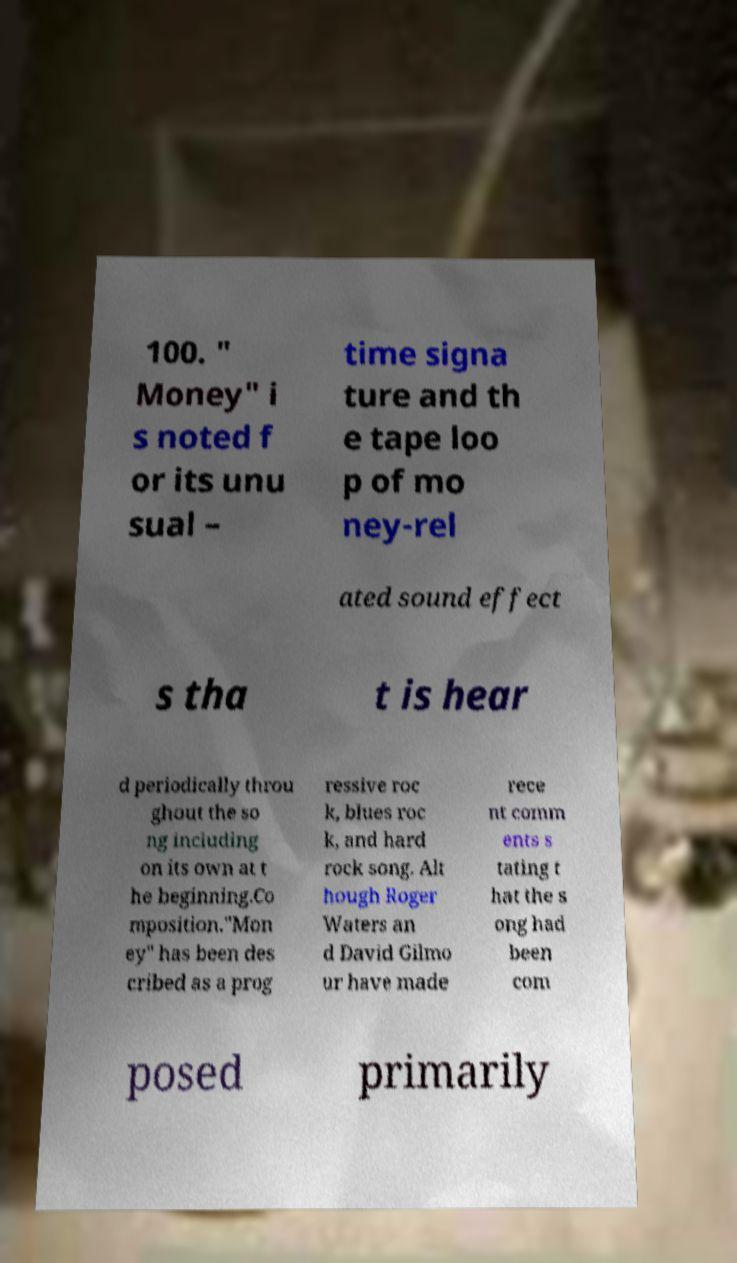Could you assist in decoding the text presented in this image and type it out clearly? 100. " Money" i s noted f or its unu sual – time signa ture and th e tape loo p of mo ney-rel ated sound effect s tha t is hear d periodically throu ghout the so ng including on its own at t he beginning.Co mposition."Mon ey" has been des cribed as a prog ressive roc k, blues roc k, and hard rock song. Alt hough Roger Waters an d David Gilmo ur have made rece nt comm ents s tating t hat the s ong had been com posed primarily 